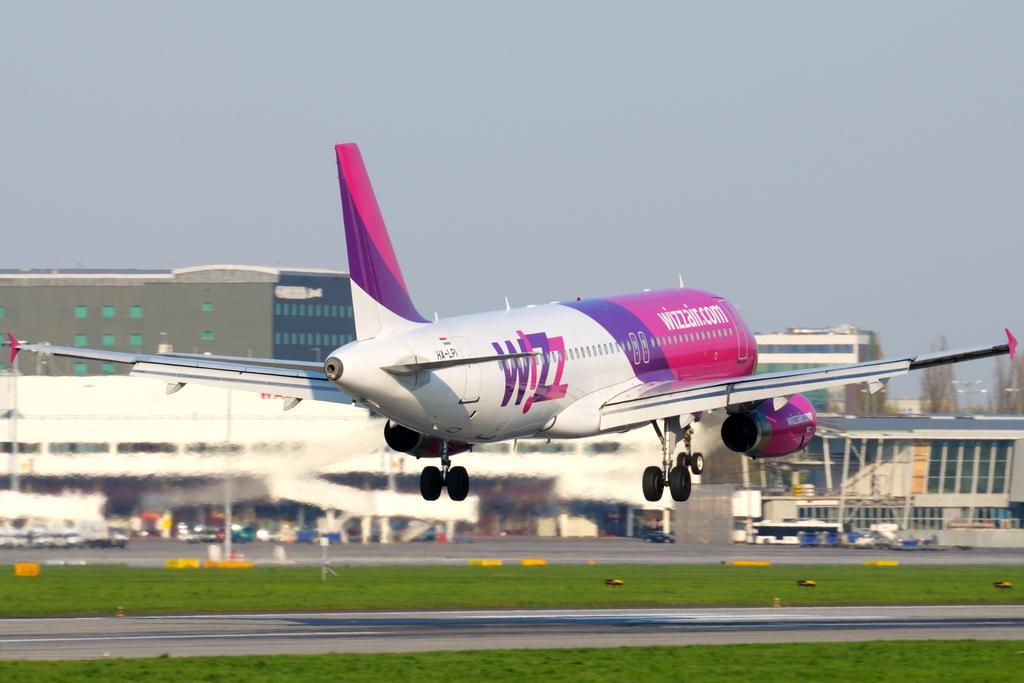Could you give a brief overview of what you see in this image? In this image, we can see an airway. We can see the ground covered with grass and some objects. We can see a few buildings and vehicles. We can see a pole and some dried trees on the right. We can see the sky. 